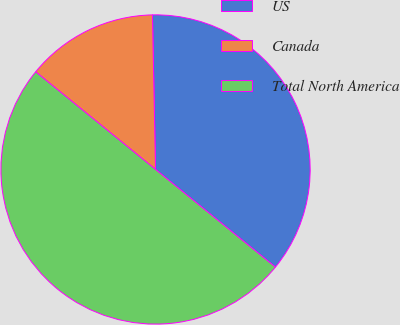<chart> <loc_0><loc_0><loc_500><loc_500><pie_chart><fcel>US<fcel>Canada<fcel>Total North America<nl><fcel>36.2%<fcel>13.8%<fcel>50.0%<nl></chart> 